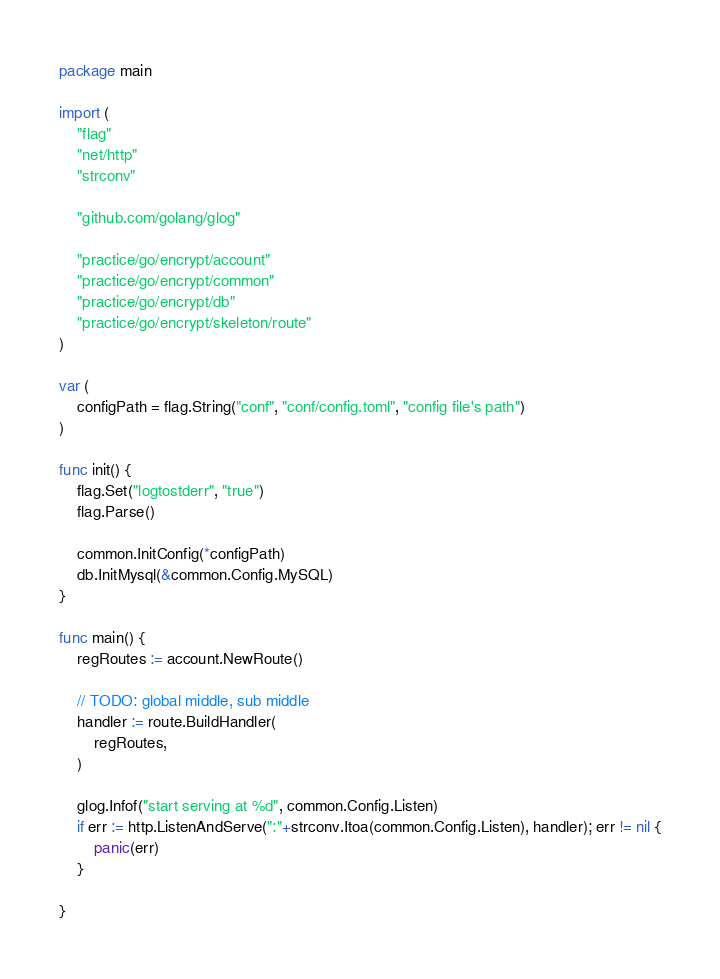<code> <loc_0><loc_0><loc_500><loc_500><_Go_>package main

import (
	"flag"
	"net/http"
	"strconv"

	"github.com/golang/glog"

	"practice/go/encrypt/account"
	"practice/go/encrypt/common"
	"practice/go/encrypt/db"
	"practice/go/encrypt/skeleton/route"
)

var (
	configPath = flag.String("conf", "conf/config.toml", "config file's path")
)

func init() {
	flag.Set("logtostderr", "true")
	flag.Parse()

	common.InitConfig(*configPath)
	db.InitMysql(&common.Config.MySQL)
}

func main() {
	regRoutes := account.NewRoute()

	// TODO: global middle, sub middle
	handler := route.BuildHandler(
		regRoutes,
	)

	glog.Infof("start serving at %d", common.Config.Listen)
	if err := http.ListenAndServe(":"+strconv.Itoa(common.Config.Listen), handler); err != nil {
		panic(err)
	}

}
</code> 